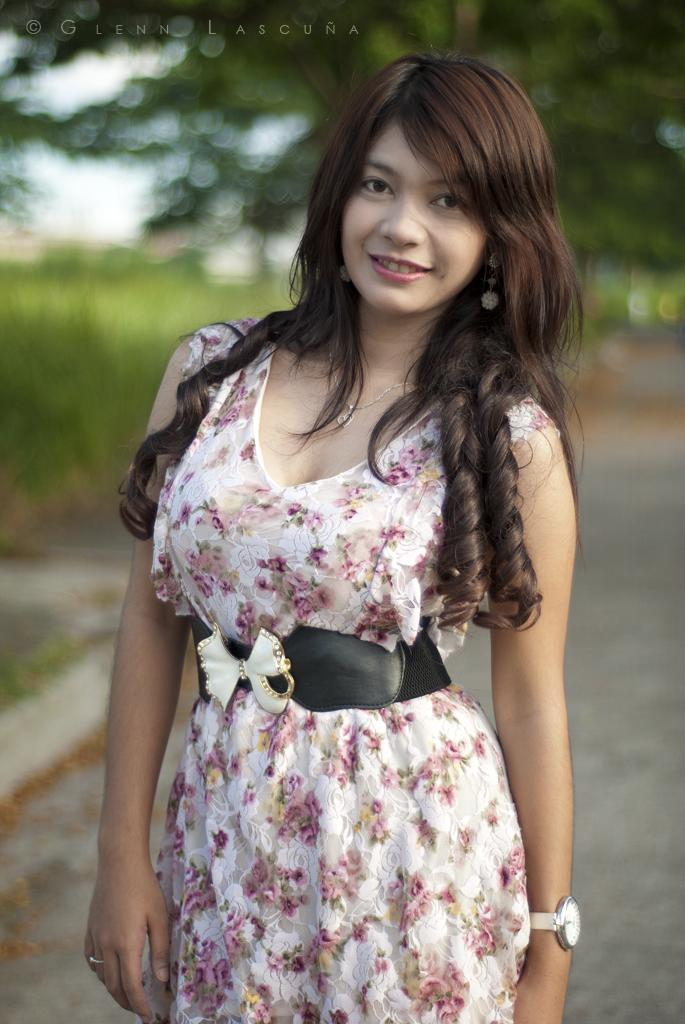Who is present in the image? There is a woman in the image. What is the woman doing in the image? The woman is standing in the image. What accessory is the woman wearing in the image? The woman is wearing a watch in the image. What can be seen in the background of the image? There are trees behind the woman in the image. How many pages are visible in the image? There are no pages present in the image. What type of mountain can be seen in the background of the image? There are no mountains visible in the image; only trees are present in the background. 